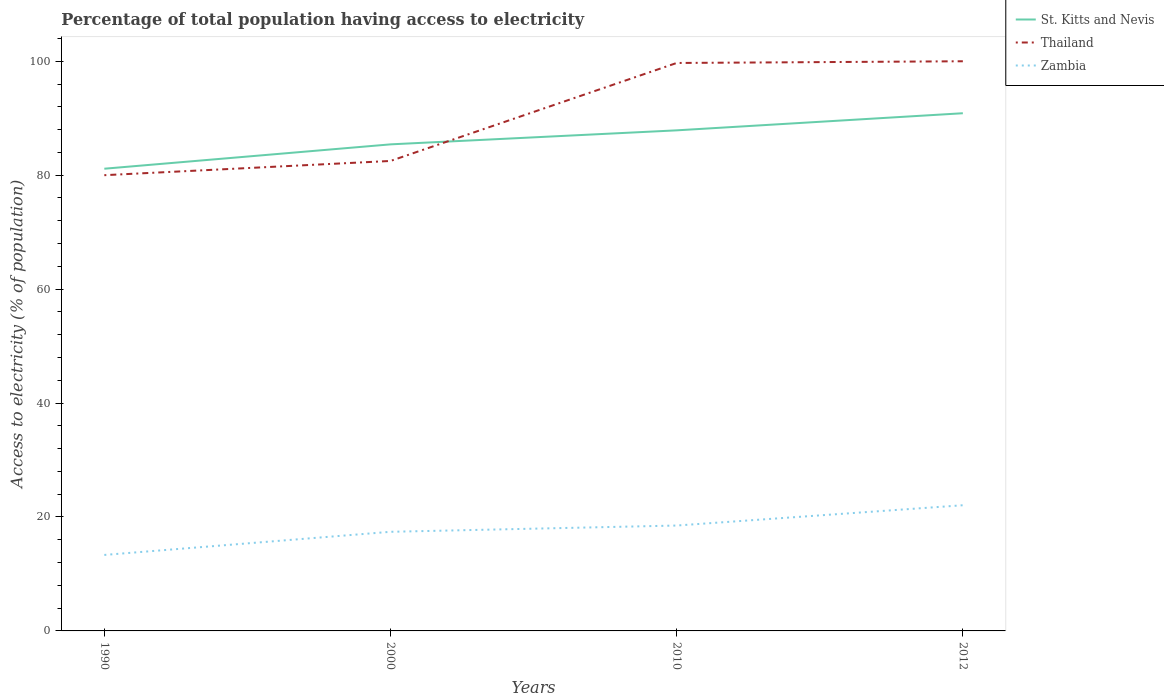How many different coloured lines are there?
Make the answer very short. 3. Across all years, what is the maximum percentage of population that have access to electricity in Zambia?
Offer a very short reply. 13.34. In which year was the percentage of population that have access to electricity in Zambia maximum?
Make the answer very short. 1990. What is the difference between the highest and the second highest percentage of population that have access to electricity in Thailand?
Keep it short and to the point. 20. Is the percentage of population that have access to electricity in Zambia strictly greater than the percentage of population that have access to electricity in Thailand over the years?
Give a very brief answer. Yes. How many lines are there?
Offer a very short reply. 3. Does the graph contain any zero values?
Your answer should be very brief. No. How are the legend labels stacked?
Your answer should be compact. Vertical. What is the title of the graph?
Make the answer very short. Percentage of total population having access to electricity. What is the label or title of the X-axis?
Ensure brevity in your answer.  Years. What is the label or title of the Y-axis?
Give a very brief answer. Access to electricity (% of population). What is the Access to electricity (% of population) in St. Kitts and Nevis in 1990?
Offer a very short reply. 81.14. What is the Access to electricity (% of population) of Thailand in 1990?
Make the answer very short. 80. What is the Access to electricity (% of population) of Zambia in 1990?
Ensure brevity in your answer.  13.34. What is the Access to electricity (% of population) in St. Kitts and Nevis in 2000?
Your response must be concise. 85.41. What is the Access to electricity (% of population) in Thailand in 2000?
Your answer should be very brief. 82.5. What is the Access to electricity (% of population) in St. Kitts and Nevis in 2010?
Give a very brief answer. 87.87. What is the Access to electricity (% of population) of Thailand in 2010?
Provide a succinct answer. 99.7. What is the Access to electricity (% of population) of Zambia in 2010?
Your response must be concise. 18.5. What is the Access to electricity (% of population) in St. Kitts and Nevis in 2012?
Provide a short and direct response. 90.88. What is the Access to electricity (% of population) in Thailand in 2012?
Your response must be concise. 100. What is the Access to electricity (% of population) in Zambia in 2012?
Provide a succinct answer. 22.06. Across all years, what is the maximum Access to electricity (% of population) in St. Kitts and Nevis?
Your answer should be very brief. 90.88. Across all years, what is the maximum Access to electricity (% of population) in Zambia?
Keep it short and to the point. 22.06. Across all years, what is the minimum Access to electricity (% of population) of St. Kitts and Nevis?
Give a very brief answer. 81.14. Across all years, what is the minimum Access to electricity (% of population) of Zambia?
Give a very brief answer. 13.34. What is the total Access to electricity (% of population) in St. Kitts and Nevis in the graph?
Offer a terse response. 345.3. What is the total Access to electricity (% of population) of Thailand in the graph?
Your answer should be very brief. 362.2. What is the total Access to electricity (% of population) in Zambia in the graph?
Offer a very short reply. 71.3. What is the difference between the Access to electricity (% of population) of St. Kitts and Nevis in 1990 and that in 2000?
Ensure brevity in your answer.  -4.28. What is the difference between the Access to electricity (% of population) in Zambia in 1990 and that in 2000?
Make the answer very short. -4.06. What is the difference between the Access to electricity (% of population) of St. Kitts and Nevis in 1990 and that in 2010?
Your answer should be compact. -6.74. What is the difference between the Access to electricity (% of population) of Thailand in 1990 and that in 2010?
Ensure brevity in your answer.  -19.7. What is the difference between the Access to electricity (% of population) of Zambia in 1990 and that in 2010?
Ensure brevity in your answer.  -5.16. What is the difference between the Access to electricity (% of population) of St. Kitts and Nevis in 1990 and that in 2012?
Ensure brevity in your answer.  -9.74. What is the difference between the Access to electricity (% of population) in Zambia in 1990 and that in 2012?
Your response must be concise. -8.72. What is the difference between the Access to electricity (% of population) of St. Kitts and Nevis in 2000 and that in 2010?
Offer a terse response. -2.46. What is the difference between the Access to electricity (% of population) in Thailand in 2000 and that in 2010?
Your answer should be compact. -17.2. What is the difference between the Access to electricity (% of population) of St. Kitts and Nevis in 2000 and that in 2012?
Your answer should be very brief. -5.46. What is the difference between the Access to electricity (% of population) in Thailand in 2000 and that in 2012?
Offer a very short reply. -17.5. What is the difference between the Access to electricity (% of population) in Zambia in 2000 and that in 2012?
Make the answer very short. -4.66. What is the difference between the Access to electricity (% of population) of St. Kitts and Nevis in 2010 and that in 2012?
Your answer should be very brief. -3. What is the difference between the Access to electricity (% of population) of Zambia in 2010 and that in 2012?
Provide a short and direct response. -3.56. What is the difference between the Access to electricity (% of population) of St. Kitts and Nevis in 1990 and the Access to electricity (% of population) of Thailand in 2000?
Provide a succinct answer. -1.36. What is the difference between the Access to electricity (% of population) in St. Kitts and Nevis in 1990 and the Access to electricity (% of population) in Zambia in 2000?
Provide a short and direct response. 63.74. What is the difference between the Access to electricity (% of population) of Thailand in 1990 and the Access to electricity (% of population) of Zambia in 2000?
Your answer should be very brief. 62.6. What is the difference between the Access to electricity (% of population) of St. Kitts and Nevis in 1990 and the Access to electricity (% of population) of Thailand in 2010?
Make the answer very short. -18.56. What is the difference between the Access to electricity (% of population) of St. Kitts and Nevis in 1990 and the Access to electricity (% of population) of Zambia in 2010?
Ensure brevity in your answer.  62.64. What is the difference between the Access to electricity (% of population) in Thailand in 1990 and the Access to electricity (% of population) in Zambia in 2010?
Keep it short and to the point. 61.5. What is the difference between the Access to electricity (% of population) of St. Kitts and Nevis in 1990 and the Access to electricity (% of population) of Thailand in 2012?
Provide a succinct answer. -18.86. What is the difference between the Access to electricity (% of population) in St. Kitts and Nevis in 1990 and the Access to electricity (% of population) in Zambia in 2012?
Your answer should be very brief. 59.07. What is the difference between the Access to electricity (% of population) of Thailand in 1990 and the Access to electricity (% of population) of Zambia in 2012?
Offer a very short reply. 57.94. What is the difference between the Access to electricity (% of population) in St. Kitts and Nevis in 2000 and the Access to electricity (% of population) in Thailand in 2010?
Give a very brief answer. -14.29. What is the difference between the Access to electricity (% of population) in St. Kitts and Nevis in 2000 and the Access to electricity (% of population) in Zambia in 2010?
Provide a succinct answer. 66.91. What is the difference between the Access to electricity (% of population) in Thailand in 2000 and the Access to electricity (% of population) in Zambia in 2010?
Your answer should be compact. 64. What is the difference between the Access to electricity (% of population) of St. Kitts and Nevis in 2000 and the Access to electricity (% of population) of Thailand in 2012?
Your answer should be very brief. -14.59. What is the difference between the Access to electricity (% of population) of St. Kitts and Nevis in 2000 and the Access to electricity (% of population) of Zambia in 2012?
Your response must be concise. 63.35. What is the difference between the Access to electricity (% of population) in Thailand in 2000 and the Access to electricity (% of population) in Zambia in 2012?
Make the answer very short. 60.44. What is the difference between the Access to electricity (% of population) in St. Kitts and Nevis in 2010 and the Access to electricity (% of population) in Thailand in 2012?
Provide a succinct answer. -12.13. What is the difference between the Access to electricity (% of population) of St. Kitts and Nevis in 2010 and the Access to electricity (% of population) of Zambia in 2012?
Offer a very short reply. 65.81. What is the difference between the Access to electricity (% of population) in Thailand in 2010 and the Access to electricity (% of population) in Zambia in 2012?
Make the answer very short. 77.64. What is the average Access to electricity (% of population) of St. Kitts and Nevis per year?
Offer a terse response. 86.32. What is the average Access to electricity (% of population) of Thailand per year?
Your answer should be very brief. 90.55. What is the average Access to electricity (% of population) in Zambia per year?
Make the answer very short. 17.83. In the year 1990, what is the difference between the Access to electricity (% of population) in St. Kitts and Nevis and Access to electricity (% of population) in Thailand?
Offer a terse response. 1.14. In the year 1990, what is the difference between the Access to electricity (% of population) of St. Kitts and Nevis and Access to electricity (% of population) of Zambia?
Your answer should be very brief. 67.8. In the year 1990, what is the difference between the Access to electricity (% of population) of Thailand and Access to electricity (% of population) of Zambia?
Offer a terse response. 66.66. In the year 2000, what is the difference between the Access to electricity (% of population) in St. Kitts and Nevis and Access to electricity (% of population) in Thailand?
Your answer should be very brief. 2.91. In the year 2000, what is the difference between the Access to electricity (% of population) in St. Kitts and Nevis and Access to electricity (% of population) in Zambia?
Give a very brief answer. 68.01. In the year 2000, what is the difference between the Access to electricity (% of population) in Thailand and Access to electricity (% of population) in Zambia?
Keep it short and to the point. 65.1. In the year 2010, what is the difference between the Access to electricity (% of population) of St. Kitts and Nevis and Access to electricity (% of population) of Thailand?
Keep it short and to the point. -11.83. In the year 2010, what is the difference between the Access to electricity (% of population) in St. Kitts and Nevis and Access to electricity (% of population) in Zambia?
Your answer should be very brief. 69.37. In the year 2010, what is the difference between the Access to electricity (% of population) of Thailand and Access to electricity (% of population) of Zambia?
Provide a short and direct response. 81.2. In the year 2012, what is the difference between the Access to electricity (% of population) of St. Kitts and Nevis and Access to electricity (% of population) of Thailand?
Offer a terse response. -9.12. In the year 2012, what is the difference between the Access to electricity (% of population) in St. Kitts and Nevis and Access to electricity (% of population) in Zambia?
Provide a succinct answer. 68.81. In the year 2012, what is the difference between the Access to electricity (% of population) in Thailand and Access to electricity (% of population) in Zambia?
Keep it short and to the point. 77.94. What is the ratio of the Access to electricity (% of population) in St. Kitts and Nevis in 1990 to that in 2000?
Offer a very short reply. 0.95. What is the ratio of the Access to electricity (% of population) in Thailand in 1990 to that in 2000?
Offer a very short reply. 0.97. What is the ratio of the Access to electricity (% of population) in Zambia in 1990 to that in 2000?
Provide a succinct answer. 0.77. What is the ratio of the Access to electricity (% of population) of St. Kitts and Nevis in 1990 to that in 2010?
Give a very brief answer. 0.92. What is the ratio of the Access to electricity (% of population) in Thailand in 1990 to that in 2010?
Your answer should be compact. 0.8. What is the ratio of the Access to electricity (% of population) in Zambia in 1990 to that in 2010?
Your answer should be very brief. 0.72. What is the ratio of the Access to electricity (% of population) in St. Kitts and Nevis in 1990 to that in 2012?
Ensure brevity in your answer.  0.89. What is the ratio of the Access to electricity (% of population) in Thailand in 1990 to that in 2012?
Make the answer very short. 0.8. What is the ratio of the Access to electricity (% of population) of Zambia in 1990 to that in 2012?
Offer a very short reply. 0.6. What is the ratio of the Access to electricity (% of population) in St. Kitts and Nevis in 2000 to that in 2010?
Your response must be concise. 0.97. What is the ratio of the Access to electricity (% of population) of Thailand in 2000 to that in 2010?
Offer a terse response. 0.83. What is the ratio of the Access to electricity (% of population) in Zambia in 2000 to that in 2010?
Offer a very short reply. 0.94. What is the ratio of the Access to electricity (% of population) of St. Kitts and Nevis in 2000 to that in 2012?
Make the answer very short. 0.94. What is the ratio of the Access to electricity (% of population) of Thailand in 2000 to that in 2012?
Offer a very short reply. 0.82. What is the ratio of the Access to electricity (% of population) in Zambia in 2000 to that in 2012?
Offer a terse response. 0.79. What is the ratio of the Access to electricity (% of population) in St. Kitts and Nevis in 2010 to that in 2012?
Keep it short and to the point. 0.97. What is the ratio of the Access to electricity (% of population) of Zambia in 2010 to that in 2012?
Your answer should be compact. 0.84. What is the difference between the highest and the second highest Access to electricity (% of population) in St. Kitts and Nevis?
Ensure brevity in your answer.  3. What is the difference between the highest and the second highest Access to electricity (% of population) of Thailand?
Your response must be concise. 0.3. What is the difference between the highest and the second highest Access to electricity (% of population) of Zambia?
Provide a short and direct response. 3.56. What is the difference between the highest and the lowest Access to electricity (% of population) in St. Kitts and Nevis?
Your answer should be compact. 9.74. What is the difference between the highest and the lowest Access to electricity (% of population) of Zambia?
Your answer should be very brief. 8.72. 